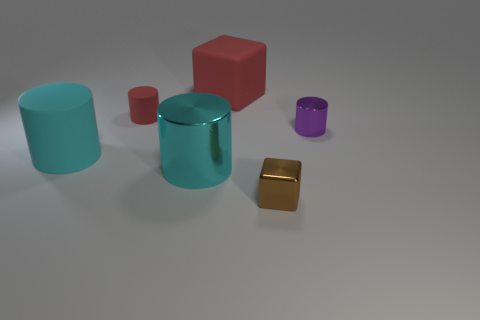Add 3 small brown objects. How many objects exist? 9 Subtract all tiny red matte cylinders. How many cylinders are left? 3 Subtract 1 cubes. How many cubes are left? 1 Subtract all cylinders. Subtract all large metal cylinders. How many objects are left? 1 Add 1 tiny metal cylinders. How many tiny metal cylinders are left? 2 Add 4 red metal cylinders. How many red metal cylinders exist? 4 Subtract all red blocks. How many blocks are left? 1 Subtract 1 red cylinders. How many objects are left? 5 Subtract all cubes. How many objects are left? 4 Subtract all blue blocks. Subtract all purple balls. How many blocks are left? 2 